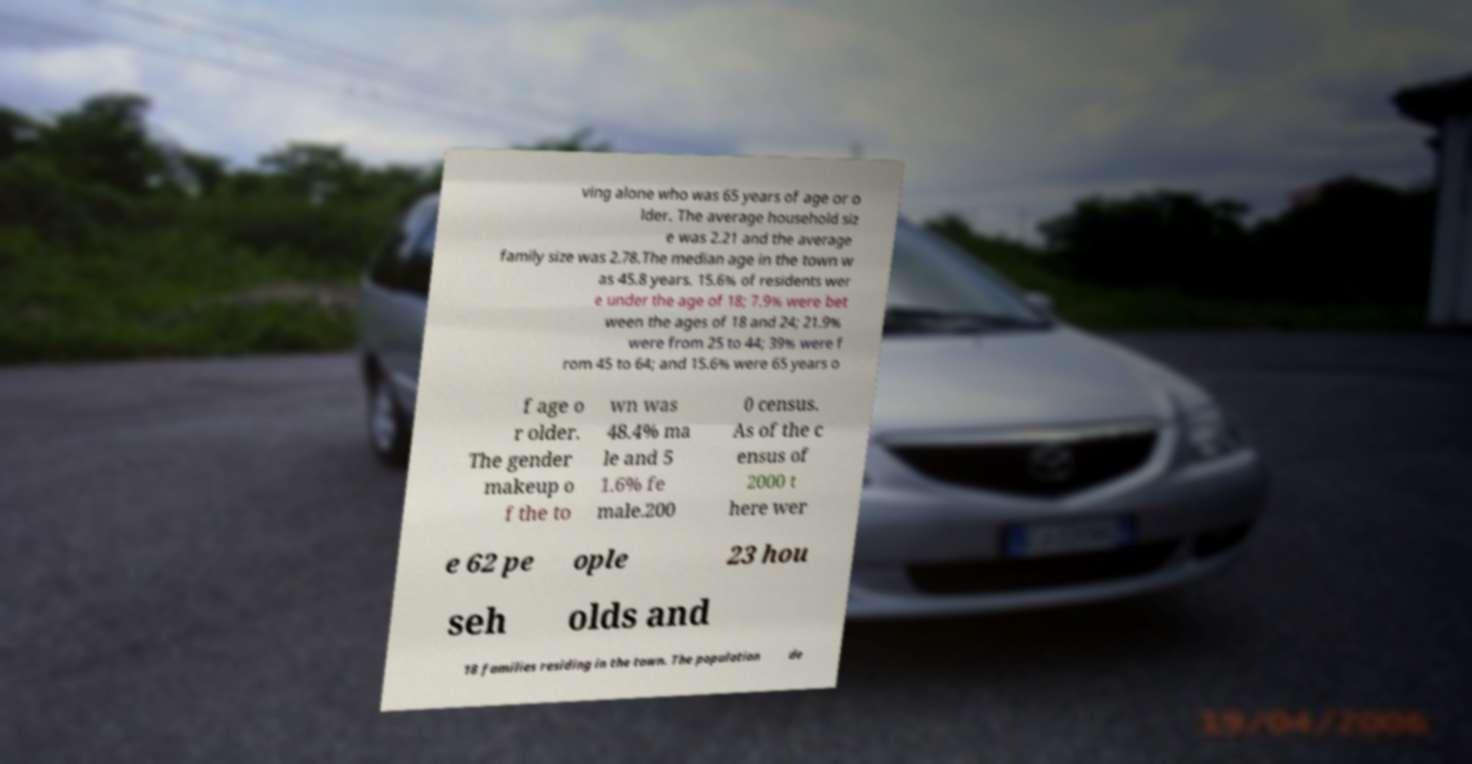Can you accurately transcribe the text from the provided image for me? ving alone who was 65 years of age or o lder. The average household siz e was 2.21 and the average family size was 2.78.The median age in the town w as 45.8 years. 15.6% of residents wer e under the age of 18; 7.9% were bet ween the ages of 18 and 24; 21.9% were from 25 to 44; 39% were f rom 45 to 64; and 15.6% were 65 years o f age o r older. The gender makeup o f the to wn was 48.4% ma le and 5 1.6% fe male.200 0 census. As of the c ensus of 2000 t here wer e 62 pe ople 23 hou seh olds and 18 families residing in the town. The population de 